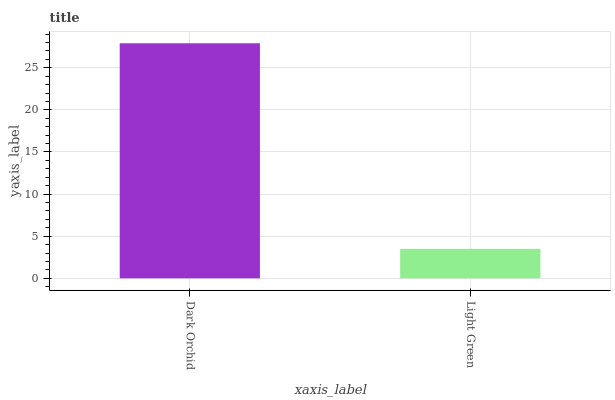Is Light Green the minimum?
Answer yes or no. Yes. Is Dark Orchid the maximum?
Answer yes or no. Yes. Is Light Green the maximum?
Answer yes or no. No. Is Dark Orchid greater than Light Green?
Answer yes or no. Yes. Is Light Green less than Dark Orchid?
Answer yes or no. Yes. Is Light Green greater than Dark Orchid?
Answer yes or no. No. Is Dark Orchid less than Light Green?
Answer yes or no. No. Is Dark Orchid the high median?
Answer yes or no. Yes. Is Light Green the low median?
Answer yes or no. Yes. Is Light Green the high median?
Answer yes or no. No. Is Dark Orchid the low median?
Answer yes or no. No. 